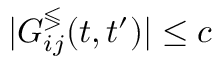Convert formula to latex. <formula><loc_0><loc_0><loc_500><loc_500>| G _ { i j } ^ { \leq s s g t r } ( t , t ^ { \prime } ) | \leq c</formula> 